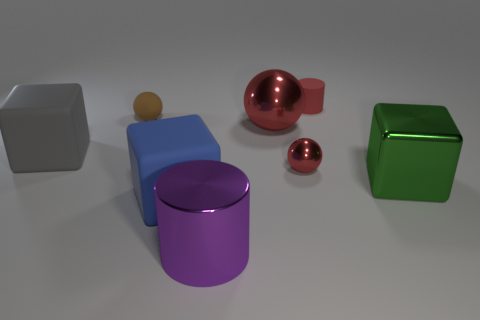Add 1 big purple cylinders. How many objects exist? 9 Subtract all purple balls. Subtract all gray cubes. How many balls are left? 3 Subtract all cubes. How many objects are left? 5 Subtract all tiny brown things. Subtract all big rubber blocks. How many objects are left? 5 Add 1 small spheres. How many small spheres are left? 3 Add 8 large blue blocks. How many large blue blocks exist? 9 Subtract 0 blue balls. How many objects are left? 8 